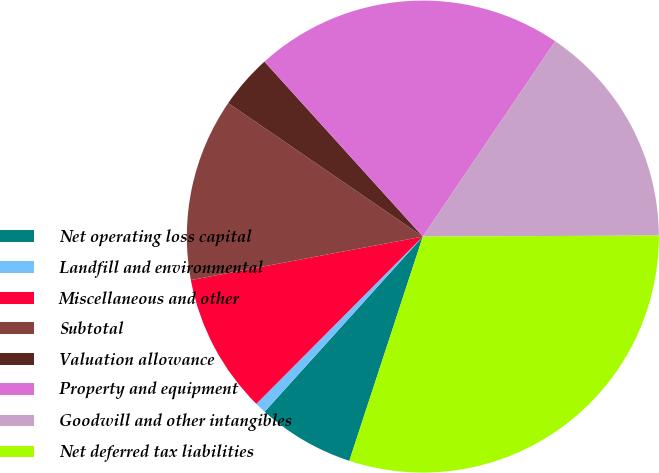Convert chart. <chart><loc_0><loc_0><loc_500><loc_500><pie_chart><fcel>Net operating loss capital<fcel>Landfill and environmental<fcel>Miscellaneous and other<fcel>Subtotal<fcel>Valuation allowance<fcel>Property and equipment<fcel>Goodwill and other intangibles<fcel>Net deferred tax liabilities<nl><fcel>6.65%<fcel>0.77%<fcel>9.59%<fcel>12.52%<fcel>3.72%<fcel>21.19%<fcel>15.45%<fcel>30.11%<nl></chart> 